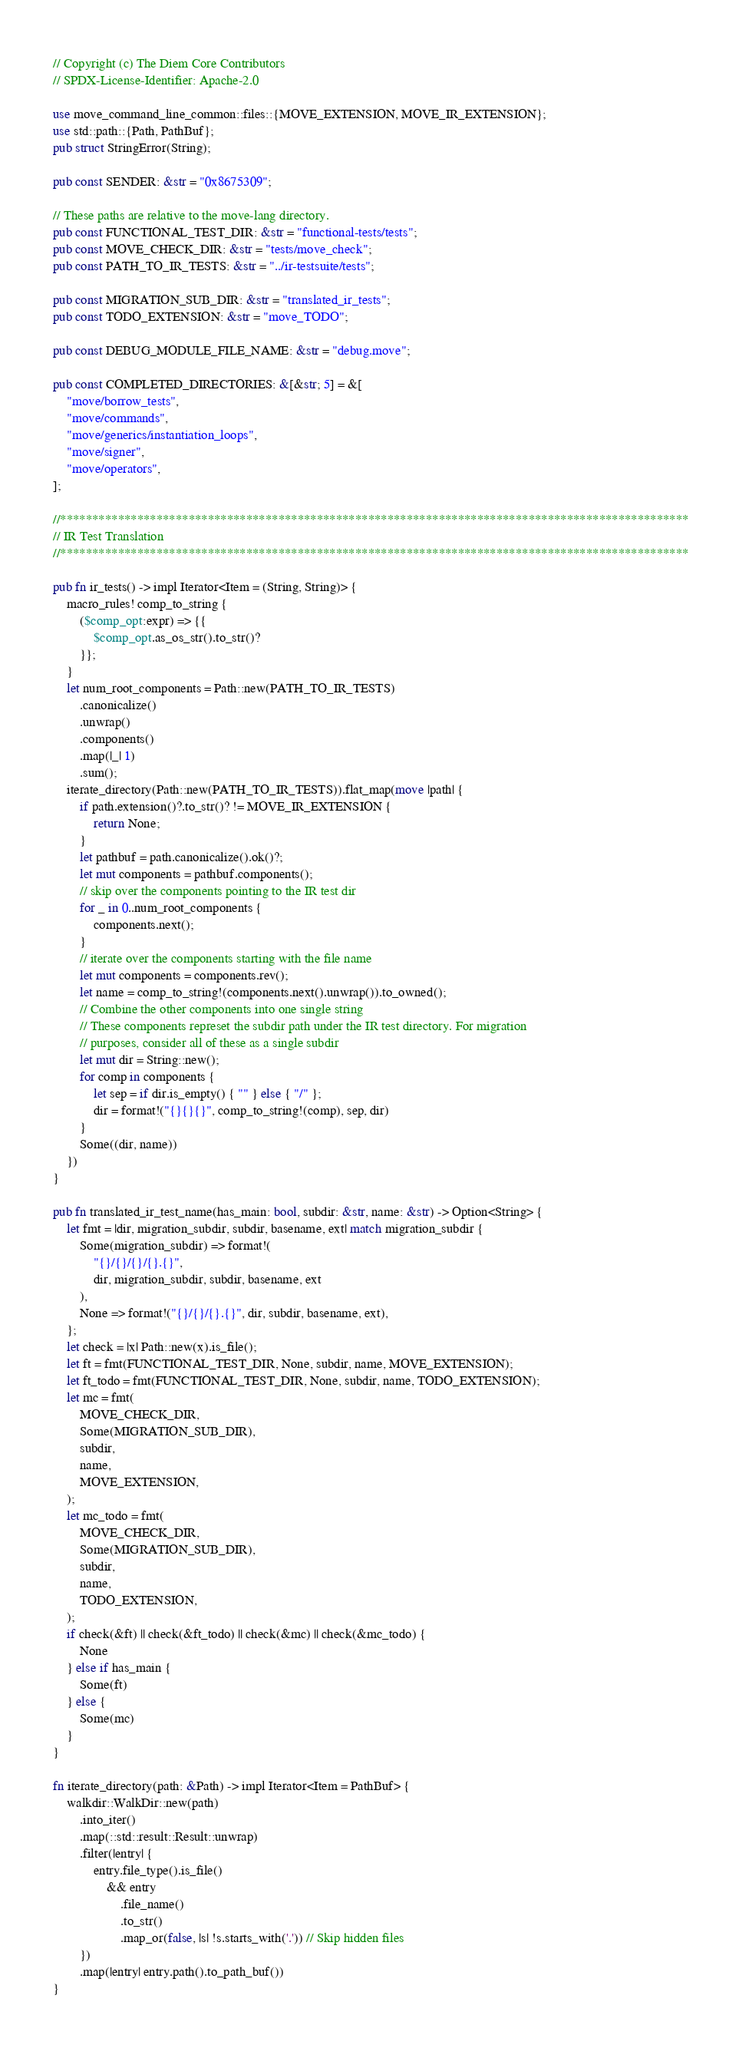<code> <loc_0><loc_0><loc_500><loc_500><_Rust_>// Copyright (c) The Diem Core Contributors
// SPDX-License-Identifier: Apache-2.0

use move_command_line_common::files::{MOVE_EXTENSION, MOVE_IR_EXTENSION};
use std::path::{Path, PathBuf};
pub struct StringError(String);

pub const SENDER: &str = "0x8675309";

// These paths are relative to the move-lang directory.
pub const FUNCTIONAL_TEST_DIR: &str = "functional-tests/tests";
pub const MOVE_CHECK_DIR: &str = "tests/move_check";
pub const PATH_TO_IR_TESTS: &str = "../ir-testsuite/tests";

pub const MIGRATION_SUB_DIR: &str = "translated_ir_tests";
pub const TODO_EXTENSION: &str = "move_TODO";

pub const DEBUG_MODULE_FILE_NAME: &str = "debug.move";

pub const COMPLETED_DIRECTORIES: &[&str; 5] = &[
    "move/borrow_tests",
    "move/commands",
    "move/generics/instantiation_loops",
    "move/signer",
    "move/operators",
];

//**************************************************************************************************
// IR Test Translation
//**************************************************************************************************

pub fn ir_tests() -> impl Iterator<Item = (String, String)> {
    macro_rules! comp_to_string {
        ($comp_opt:expr) => {{
            $comp_opt.as_os_str().to_str()?
        }};
    }
    let num_root_components = Path::new(PATH_TO_IR_TESTS)
        .canonicalize()
        .unwrap()
        .components()
        .map(|_| 1)
        .sum();
    iterate_directory(Path::new(PATH_TO_IR_TESTS)).flat_map(move |path| {
        if path.extension()?.to_str()? != MOVE_IR_EXTENSION {
            return None;
        }
        let pathbuf = path.canonicalize().ok()?;
        let mut components = pathbuf.components();
        // skip over the components pointing to the IR test dir
        for _ in 0..num_root_components {
            components.next();
        }
        // iterate over the components starting with the file name
        let mut components = components.rev();
        let name = comp_to_string!(components.next().unwrap()).to_owned();
        // Combine the other components into one single string
        // These components represet the subdir path under the IR test directory. For migration
        // purposes, consider all of these as a single subdir
        let mut dir = String::new();
        for comp in components {
            let sep = if dir.is_empty() { "" } else { "/" };
            dir = format!("{}{}{}", comp_to_string!(comp), sep, dir)
        }
        Some((dir, name))
    })
}

pub fn translated_ir_test_name(has_main: bool, subdir: &str, name: &str) -> Option<String> {
    let fmt = |dir, migration_subdir, subdir, basename, ext| match migration_subdir {
        Some(migration_subdir) => format!(
            "{}/{}/{}/{}.{}",
            dir, migration_subdir, subdir, basename, ext
        ),
        None => format!("{}/{}/{}.{}", dir, subdir, basename, ext),
    };
    let check = |x| Path::new(x).is_file();
    let ft = fmt(FUNCTIONAL_TEST_DIR, None, subdir, name, MOVE_EXTENSION);
    let ft_todo = fmt(FUNCTIONAL_TEST_DIR, None, subdir, name, TODO_EXTENSION);
    let mc = fmt(
        MOVE_CHECK_DIR,
        Some(MIGRATION_SUB_DIR),
        subdir,
        name,
        MOVE_EXTENSION,
    );
    let mc_todo = fmt(
        MOVE_CHECK_DIR,
        Some(MIGRATION_SUB_DIR),
        subdir,
        name,
        TODO_EXTENSION,
    );
    if check(&ft) || check(&ft_todo) || check(&mc) || check(&mc_todo) {
        None
    } else if has_main {
        Some(ft)
    } else {
        Some(mc)
    }
}

fn iterate_directory(path: &Path) -> impl Iterator<Item = PathBuf> {
    walkdir::WalkDir::new(path)
        .into_iter()
        .map(::std::result::Result::unwrap)
        .filter(|entry| {
            entry.file_type().is_file()
                && entry
                    .file_name()
                    .to_str()
                    .map_or(false, |s| !s.starts_with('.')) // Skip hidden files
        })
        .map(|entry| entry.path().to_path_buf())
}
</code> 